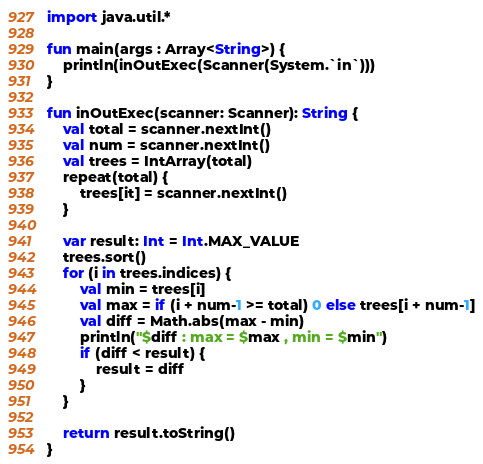<code> <loc_0><loc_0><loc_500><loc_500><_Kotlin_>import java.util.*

fun main(args : Array<String>) {
    println(inOutExec(Scanner(System.`in`)))
}

fun inOutExec(scanner: Scanner): String {
    val total = scanner.nextInt()
    val num = scanner.nextInt()
    val trees = IntArray(total)
    repeat(total) {
        trees[it] = scanner.nextInt()
    }

    var result: Int = Int.MAX_VALUE
    trees.sort()
    for (i in trees.indices) {
        val min = trees[i]
        val max = if (i + num-1 >= total) 0 else trees[i + num-1]
        val diff = Math.abs(max - min)
        println("$diff : max = $max , min = $min")
        if (diff < result) {
            result = diff
        }
    }

    return result.toString()
}</code> 